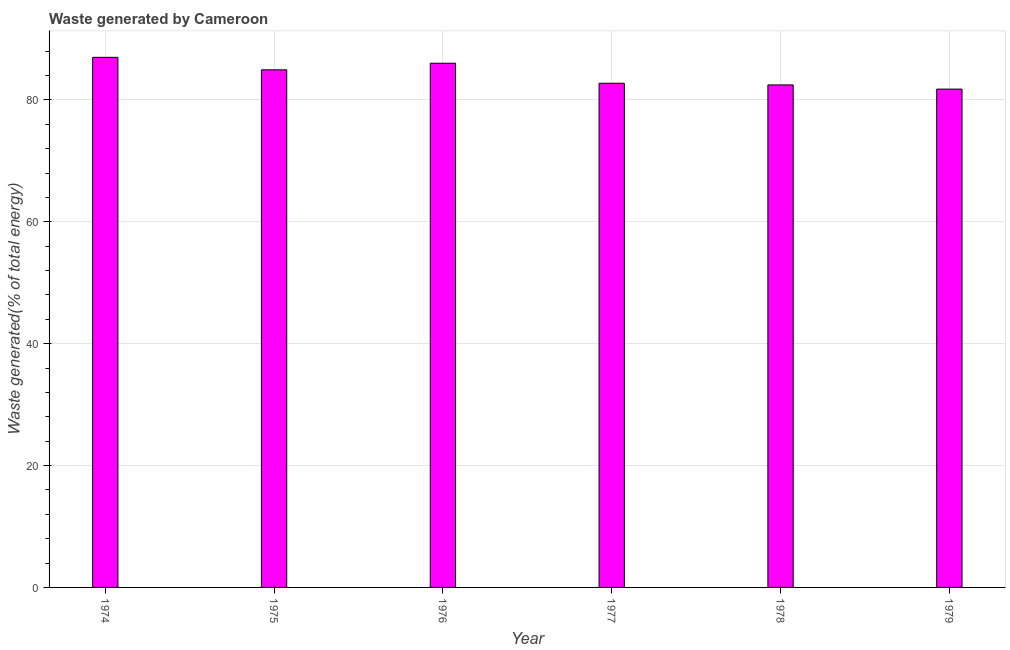Does the graph contain any zero values?
Offer a very short reply. No. Does the graph contain grids?
Your answer should be very brief. Yes. What is the title of the graph?
Your answer should be compact. Waste generated by Cameroon. What is the label or title of the Y-axis?
Provide a succinct answer. Waste generated(% of total energy). What is the amount of waste generated in 1979?
Provide a succinct answer. 81.78. Across all years, what is the maximum amount of waste generated?
Your response must be concise. 86.99. Across all years, what is the minimum amount of waste generated?
Your response must be concise. 81.78. In which year was the amount of waste generated maximum?
Ensure brevity in your answer.  1974. In which year was the amount of waste generated minimum?
Make the answer very short. 1979. What is the sum of the amount of waste generated?
Your answer should be compact. 504.93. What is the difference between the amount of waste generated in 1975 and 1978?
Offer a terse response. 2.48. What is the average amount of waste generated per year?
Provide a succinct answer. 84.16. What is the median amount of waste generated?
Your response must be concise. 83.84. Do a majority of the years between 1976 and 1979 (inclusive) have amount of waste generated greater than 56 %?
Ensure brevity in your answer.  Yes. Is the sum of the amount of waste generated in 1975 and 1977 greater than the maximum amount of waste generated across all years?
Provide a succinct answer. Yes. What is the difference between the highest and the lowest amount of waste generated?
Your response must be concise. 5.21. In how many years, is the amount of waste generated greater than the average amount of waste generated taken over all years?
Your answer should be compact. 3. How many bars are there?
Your response must be concise. 6. Are all the bars in the graph horizontal?
Provide a succinct answer. No. How many years are there in the graph?
Keep it short and to the point. 6. What is the Waste generated(% of total energy) in 1974?
Provide a short and direct response. 86.99. What is the Waste generated(% of total energy) in 1975?
Provide a succinct answer. 84.94. What is the Waste generated(% of total energy) in 1976?
Give a very brief answer. 86.02. What is the Waste generated(% of total energy) in 1977?
Your answer should be very brief. 82.74. What is the Waste generated(% of total energy) of 1978?
Offer a terse response. 82.46. What is the Waste generated(% of total energy) of 1979?
Ensure brevity in your answer.  81.78. What is the difference between the Waste generated(% of total energy) in 1974 and 1975?
Your answer should be very brief. 2.05. What is the difference between the Waste generated(% of total energy) in 1974 and 1976?
Ensure brevity in your answer.  0.97. What is the difference between the Waste generated(% of total energy) in 1974 and 1977?
Provide a short and direct response. 4.25. What is the difference between the Waste generated(% of total energy) in 1974 and 1978?
Offer a terse response. 4.53. What is the difference between the Waste generated(% of total energy) in 1974 and 1979?
Ensure brevity in your answer.  5.21. What is the difference between the Waste generated(% of total energy) in 1975 and 1976?
Keep it short and to the point. -1.08. What is the difference between the Waste generated(% of total energy) in 1975 and 1977?
Make the answer very short. 2.2. What is the difference between the Waste generated(% of total energy) in 1975 and 1978?
Provide a short and direct response. 2.48. What is the difference between the Waste generated(% of total energy) in 1975 and 1979?
Provide a succinct answer. 3.16. What is the difference between the Waste generated(% of total energy) in 1976 and 1977?
Make the answer very short. 3.29. What is the difference between the Waste generated(% of total energy) in 1976 and 1978?
Ensure brevity in your answer.  3.56. What is the difference between the Waste generated(% of total energy) in 1976 and 1979?
Your answer should be compact. 4.25. What is the difference between the Waste generated(% of total energy) in 1977 and 1978?
Your response must be concise. 0.27. What is the difference between the Waste generated(% of total energy) in 1977 and 1979?
Keep it short and to the point. 0.96. What is the difference between the Waste generated(% of total energy) in 1978 and 1979?
Your answer should be very brief. 0.69. What is the ratio of the Waste generated(% of total energy) in 1974 to that in 1975?
Make the answer very short. 1.02. What is the ratio of the Waste generated(% of total energy) in 1974 to that in 1976?
Your answer should be very brief. 1.01. What is the ratio of the Waste generated(% of total energy) in 1974 to that in 1977?
Make the answer very short. 1.05. What is the ratio of the Waste generated(% of total energy) in 1974 to that in 1978?
Your answer should be compact. 1.05. What is the ratio of the Waste generated(% of total energy) in 1974 to that in 1979?
Make the answer very short. 1.06. What is the ratio of the Waste generated(% of total energy) in 1975 to that in 1977?
Provide a succinct answer. 1.03. What is the ratio of the Waste generated(% of total energy) in 1975 to that in 1978?
Offer a terse response. 1.03. What is the ratio of the Waste generated(% of total energy) in 1975 to that in 1979?
Your answer should be very brief. 1.04. What is the ratio of the Waste generated(% of total energy) in 1976 to that in 1977?
Keep it short and to the point. 1.04. What is the ratio of the Waste generated(% of total energy) in 1976 to that in 1978?
Ensure brevity in your answer.  1.04. What is the ratio of the Waste generated(% of total energy) in 1976 to that in 1979?
Ensure brevity in your answer.  1.05. What is the ratio of the Waste generated(% of total energy) in 1977 to that in 1978?
Provide a short and direct response. 1. 